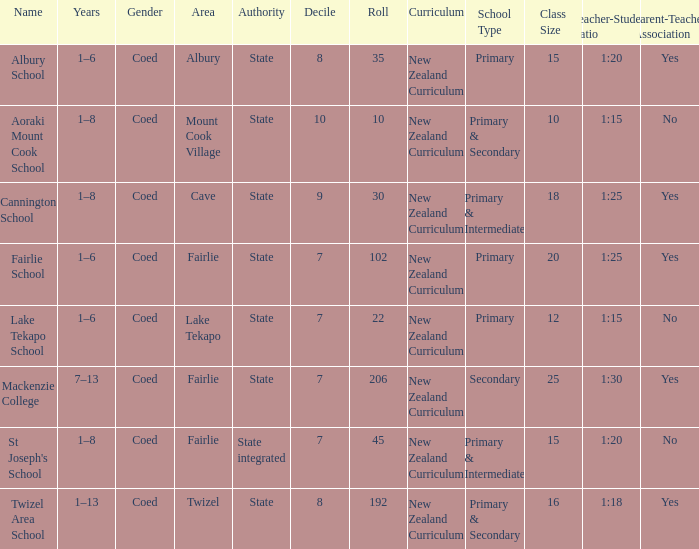What area is named Mackenzie college? Fairlie. 